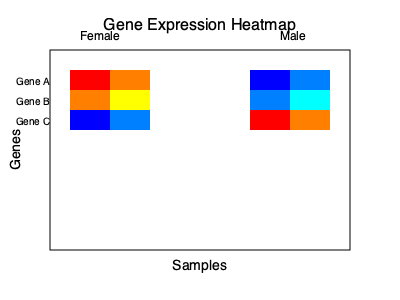Based on the gene expression heatmap provided, which gene shows the most striking difference in expression between male and female samples? To answer this question, we need to analyze the heatmap and compare the expression patterns between male and female samples for each gene:

1. Interpret the heatmap:
   - The left side represents female samples, and the right side represents male samples.
   - Red colors indicate high expression, blue colors indicate low expression, and yellow/green colors indicate moderate expression.

2. Analyze Gene A (top row):
   - Female samples: Red to orange (high expression)
   - Male samples: Blue (low expression)
   - There is a clear difference between male and female samples.

3. Analyze Gene B (middle row):
   - Female samples: Orange to yellow (moderate to high expression)
   - Male samples: Light blue to cyan (low to moderate expression)
   - There is a noticeable difference, but less striking than Gene A.

4. Analyze Gene C (bottom row):
   - Female samples: Blue (low expression)
   - Male samples: Red to orange (high expression)
   - There is a clear difference between male and female samples, opposite to Gene A.

5. Compare the differences:
   - Both Gene A and Gene C show striking differences between male and female samples.
   - Gene B shows a less pronounced difference.
   - Gene A and Gene C have opposite patterns, with Gene A being high in females and low in males, while Gene C is low in females and high in males.

6. Conclusion:
   Both Gene A and Gene C show striking differences, but Gene A is slightly more pronounced due to the deeper red color in female samples compared to the orange in male samples for Gene C.
Answer: Gene A 